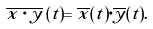<formula> <loc_0><loc_0><loc_500><loc_500>\overline { x \cdot y } \, ( t ) = \overline { x } ( t ) \cdot \overline { y } ( t ) .</formula> 